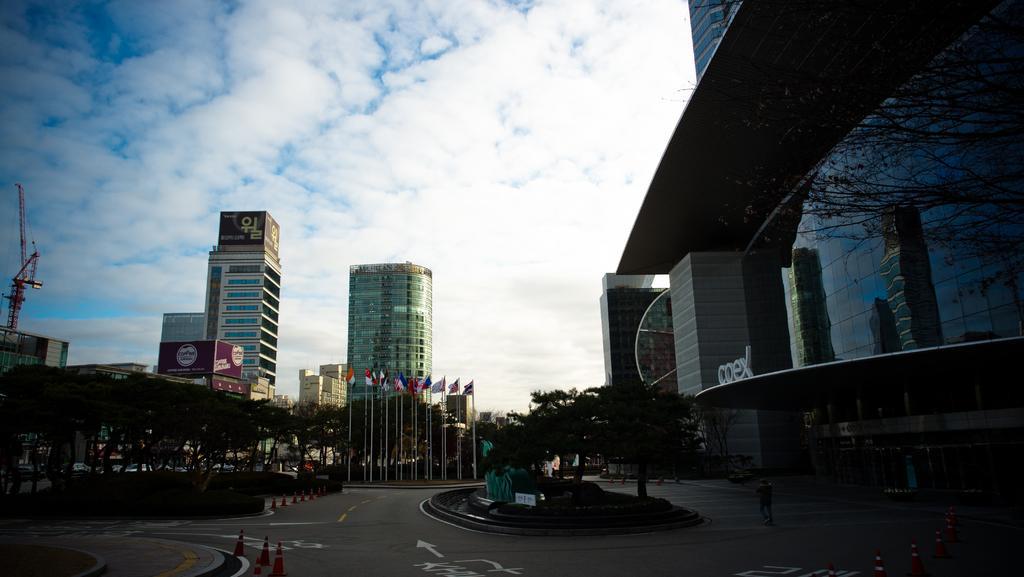Please provide a concise description of this image. This is the picture of a city. In this image there are buildings and in the foreground there are flags and trees. On the left side of the image there is a crane. There are hoardings on the buildings and there is a text on the building. At the top there is sky and there are clouds. At the bottom there is a road and there is a person walking on the road. 